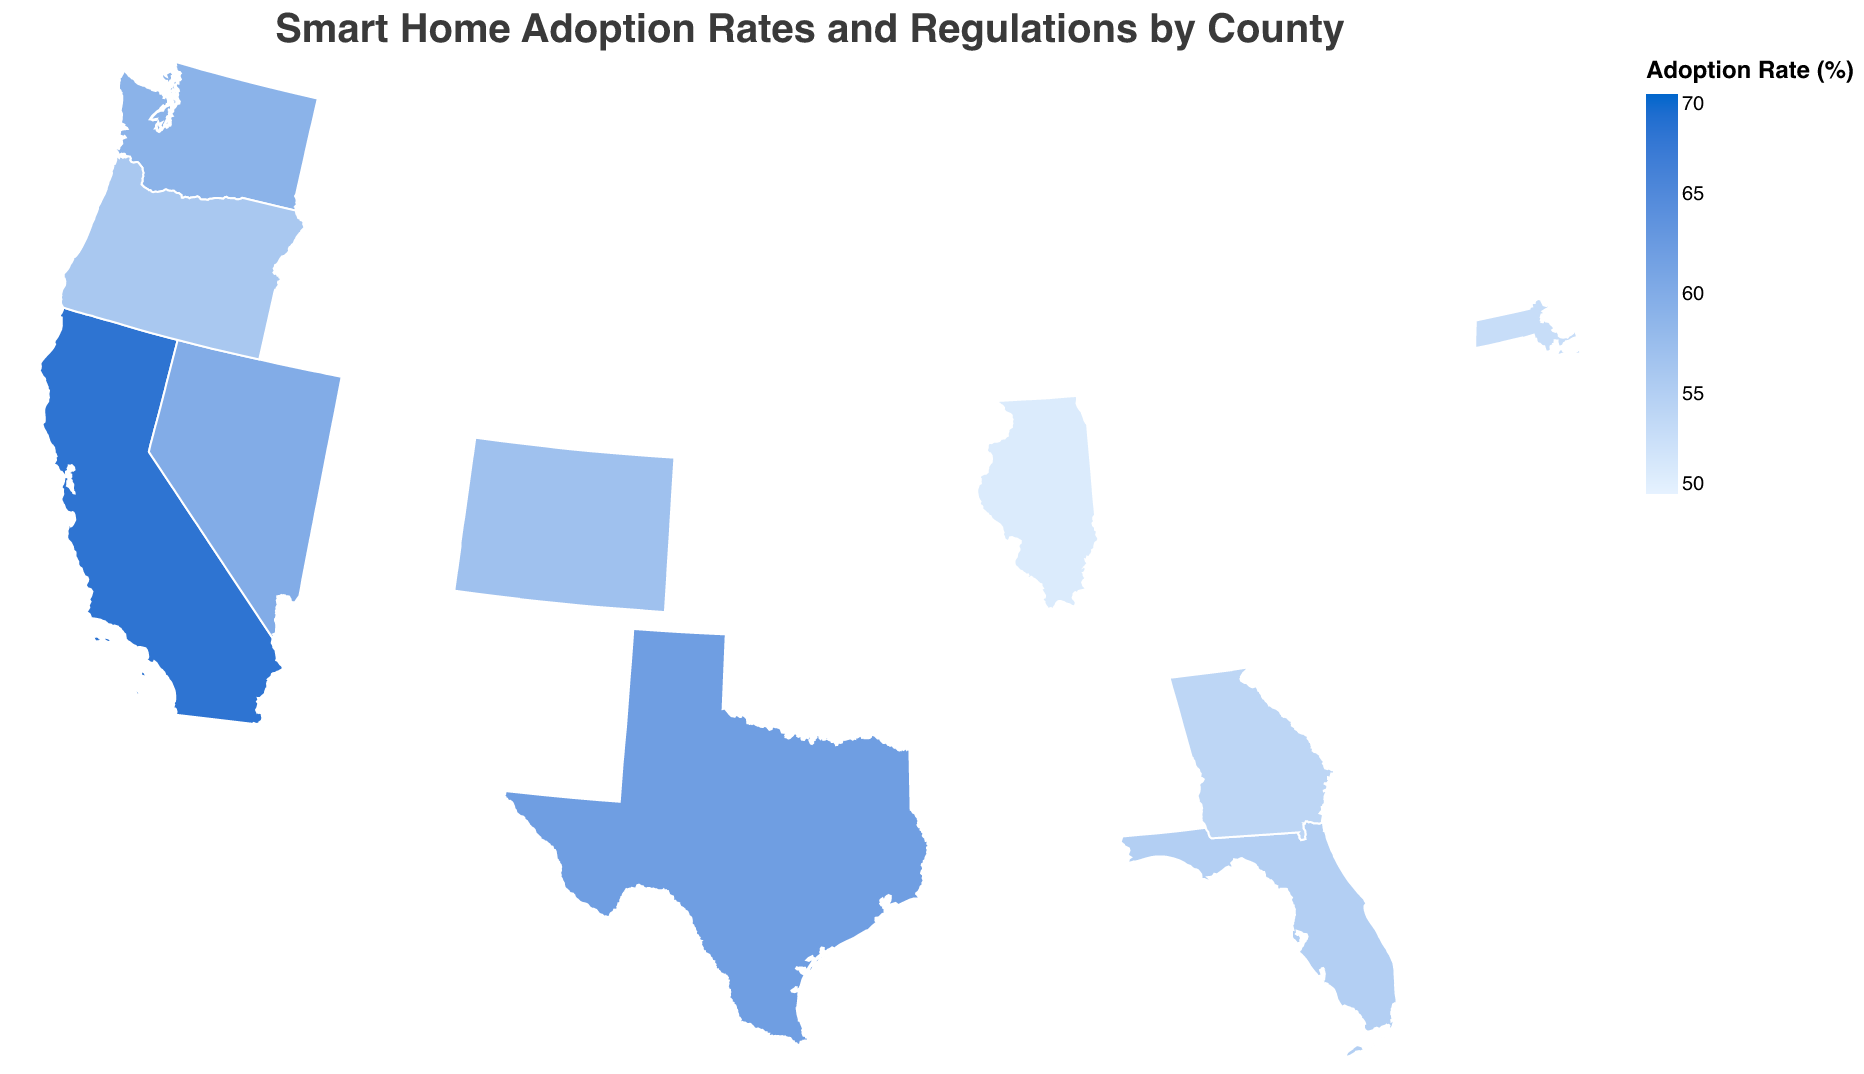What's the highest smart home adoption rate, and which county is it? The color scale indicates adoption rates, with darker colors representing higher rates. San Francisco, California has the highest rate at 68%.
Answer: San Francisco, California, 68% Which county in Texas has specific local regulations and incentives for smart home installations? The tooltip provides specific local regulations and incentives when hovering over counties. Austin, Texas is displayed with the relevant details.
Answer: Austin, Texas How do the smart home adoption rates compare between Denver, Colorado and Miami-Dade, Florida? By referring to the color intensity and the tooltip information:
- Denver has an adoption rate of 57%.
- Miami-Dade has an adoption rate of 55%. Denver's rate is higher than Miami-Dade's.
Answer: Denver 57%, Miami-Dade 55% What is the average smart home adoption rate across all counties? To find the average, sum all the adoption rates: (68 + 62 + 59 + 55 + 57 + 53 + 51 + 60 + 56 + 54) = 575. Then divide by the number of counties, which is 10. So, 575/10 = 57.5
Answer: 57.5% Describe the regulations and incentives for smart home installations in Chicago, Illinois. The tooltip provides detailed information:
- Regulation: Data privacy laws for smart home devices
- Incentive: Rebates on smart lighting systems
Answer: Data privacy laws; Rebates on smart lighting systems What correlations can you infer between the given incentives and the smart home adoption rates across the counties? Analyze the plot and the tooltip information for each county to determine if certain types of incentives are associated with higher adoption rates. For example, counties with significant financial incentives like tax credits (San Francisco, Austin), rebates (Portland, Las Vegas, Denver), and grants (Miami-Dade) tend to have higher adoption rates.
Answer: Financial incentives correlate with higher adoption Which county has noise reduction regulations for smart devices and what is its adoption rate? Referring to the tooltip, Boston, Massachusetts has noise reduction regulations and a smart home adoption rate of 53%.
Answer: Boston, Massachusetts, 53% What unique smart home accessibility standard is there in Atlanta, Georgia, and what is the incentive for full home automation? The tooltip shows Atlanta's regulation as "Smart home accessibility standards for seniors" and the incentive is "Property tax breaks for full home automation."
Answer: Accessibility standards for seniors; Property tax breaks 